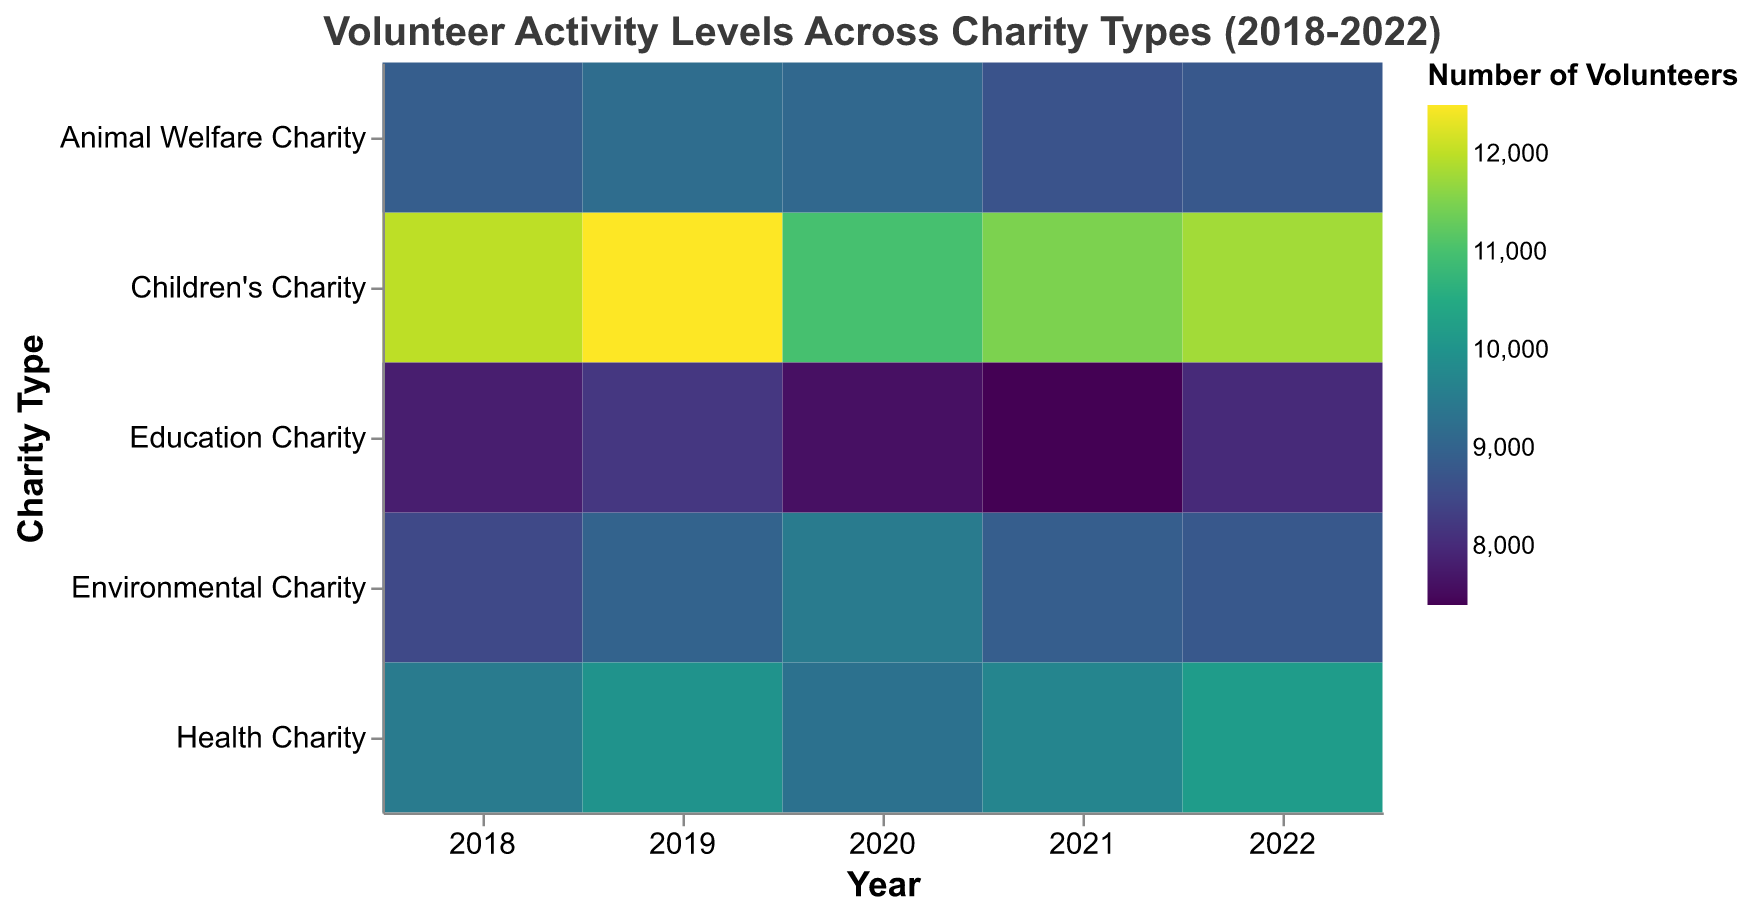What is the title of the heatmap? The title is usually located at the top center of the figure. It provides a summary of what the heatmap represents.
Answer: Volunteer Activity Levels Across Charity Types (2018-2022) Which year had the highest number of volunteers for Health Charity? To find this, locate the row for Health Charity and identify the year with the darkest color, which represents the highest number of volunteers.
Answer: 2022 How many years are represented in the heatmap? Look at the x-axis where the years are labeled. Count the number of distinct labels along this axis.
Answer: 5 What is the volunteer trend for Children's Charity from 2018 to 2022? Observe the color intensity in the Children's Charity row from 2018 to 2022. Note the changes in color to determine if the number of volunteers increases, decreases, or stays the same.
Answer: Generally increasing Which charity type had the lowest volunteer count in 2021? Find the year 2021 on the x-axis, then look for the row with the lightest color, which indicates the lowest number of volunteers.
Answer: Education Charity Compare the volunteer numbers between Environmental Charity and Animal Welfare Charity in 2020. Which had more volunteers? Locate both Environmental Charity and Animal Welfare Charity rows for the year 2020, then compare the color intensities. The darker color indicates a higher number of volunteers.
Answer: Environmental Charity What is the average number of volunteers for Education Charity over the five years? Sum the number of volunteers for Education Charity from 2018 to 2022 and divide by 5. (7800 + 8200 + 7600 + 7400 + 8000) / 5 = 38000 / 5
Answer: 7600 In which year did Environmental Charity see the highest increase in volunteers compared to the previous year? Calculate the differences in volunteer numbers for Environmental Charity year by year and identify the year with the largest positive difference.
Answer: 2020 Which charity type saw the most consistent volunteer activity levels over the five years? Compare the color intensity variations across the rows for each charity. The row with the least variation in color has the most consistent volunteer activity levels.
Answer: Animal Welfare Charity How did the volunteer count for Health Charity change from 2019 to 2020? Compare the color intensity for Health Charity in 2019 and 2020. Note if the color got darker, lighter, or stayed the same.
Answer: Decreased 